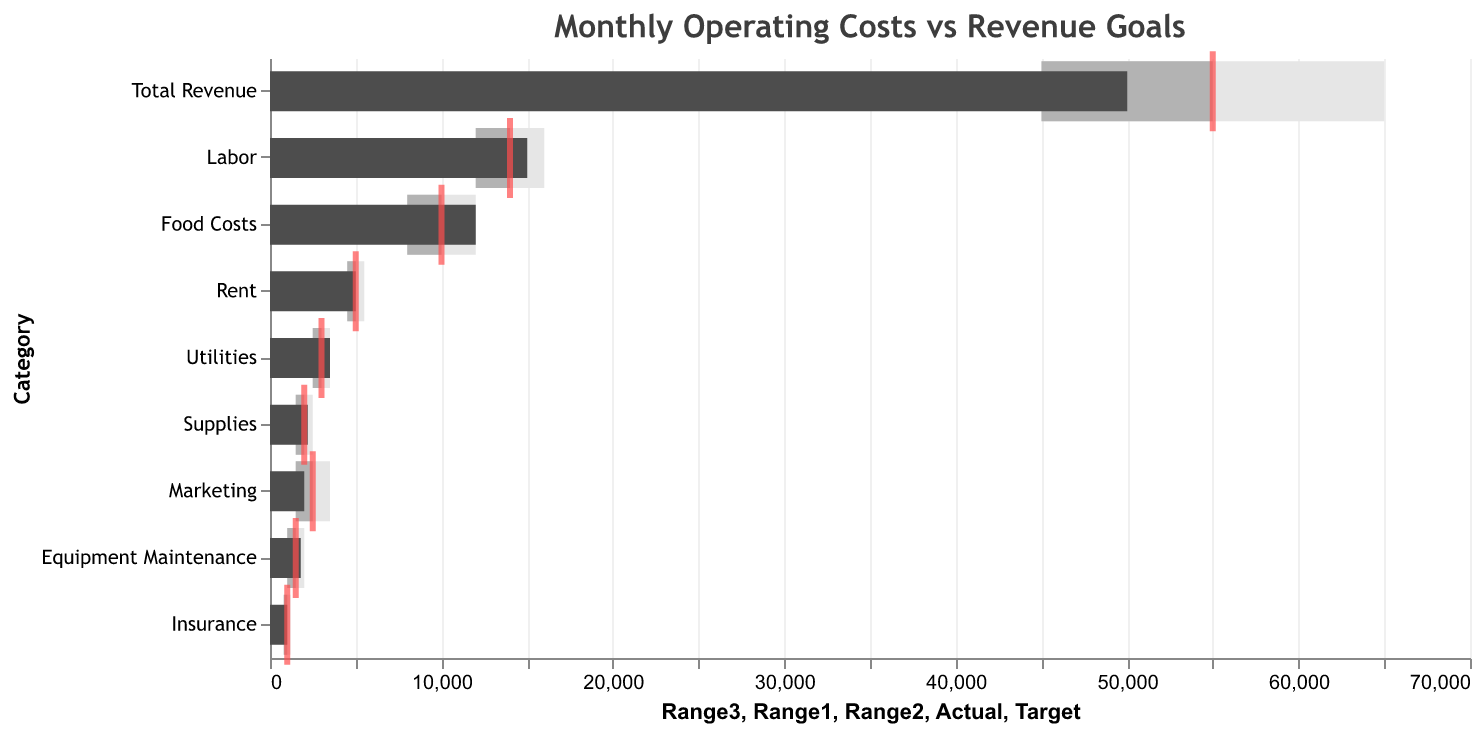What is the title of the figure? The title of the figure is mentioned at the top, "Monthly Operating Costs vs Revenue Goals".
Answer: Monthly Operating Costs vs Revenue Goals Which category has the lowest actual cost? By examining the bars representing actual costs, the lowest bar is for Insurance with an actual cost of 1000.
Answer: Insurance How does the actual marketing expenditure compare to its target? The actual marketing expenditure (2000) is represented by a dark gray bar, which is lower than the target indicated by a red tick at 2500.
Answer: It is lower What are the actual and target costs for labor? The bar representing the actual costs shows 15000, and the tick representing the target cost indicates 14000 for labor.
Answer: Actual: 15000, Target: 14000 Which category's actual cost exceeds the target by the largest margin? By comparing the actual and target values for each category, Food Costs have an actual cost of 12000 and a target of 10000, exceeding the target by 2000.
Answer: Food Costs How much does the actual total revenue fall short of the target? The actual total revenue is 50000, and the target is 55000. The difference is 55000 - 50000 = 5000.
Answer: 5000 How many categories have actual costs within their target range? Rent and Insurance have actual costs that exactly meet their targets, and Food Costs, Labor, Utilities, Marketing, Equipment Maintenance, and Supplies all fall within their target ranges.
Answer: 8 categories Compare the actual and target costs for supplies. Is the actual higher, lower, or equal? The actual cost for supplies is 2200, which is higher than the target cost of 2000.
Answer: Higher Which category has the smallest difference between its actual and target costs? By evaluating the differences between actual and target costs, Rent has a difference of 0 (5000 - 5000).
Answer: Rent What is the combined actual expenditure for Utilities and Marketing? Adding up the actual expenditures for Utilities (3500) and Marketing (2000) gives 3500 + 2000 = 5500.
Answer: 5500 Is the actual total revenue within the target range? The target range for total revenue is from 45000 to 65000. The actual total revenue is 50000, which falls within this range.
Answer: Yes 